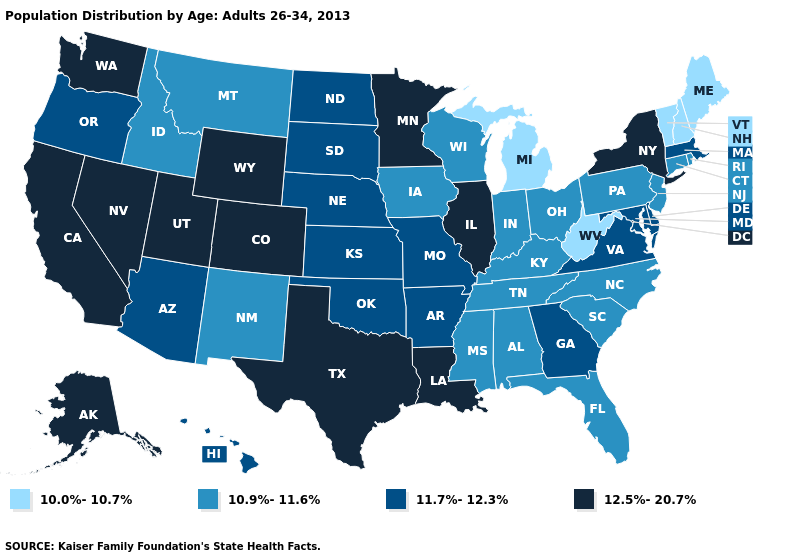Which states hav the highest value in the West?
Concise answer only. Alaska, California, Colorado, Nevada, Utah, Washington, Wyoming. Does the map have missing data?
Answer briefly. No. Name the states that have a value in the range 11.7%-12.3%?
Short answer required. Arizona, Arkansas, Delaware, Georgia, Hawaii, Kansas, Maryland, Massachusetts, Missouri, Nebraska, North Dakota, Oklahoma, Oregon, South Dakota, Virginia. Name the states that have a value in the range 12.5%-20.7%?
Answer briefly. Alaska, California, Colorado, Illinois, Louisiana, Minnesota, Nevada, New York, Texas, Utah, Washington, Wyoming. What is the value of Oklahoma?
Answer briefly. 11.7%-12.3%. What is the value of South Dakota?
Concise answer only. 11.7%-12.3%. What is the highest value in states that border Pennsylvania?
Answer briefly. 12.5%-20.7%. Does Virginia have the same value as Georgia?
Write a very short answer. Yes. Does Minnesota have the highest value in the MidWest?
Be succinct. Yes. Does Illinois have a higher value than New Hampshire?
Answer briefly. Yes. What is the value of Oklahoma?
Answer briefly. 11.7%-12.3%. Among the states that border Oregon , which have the highest value?
Write a very short answer. California, Nevada, Washington. What is the value of Oklahoma?
Keep it brief. 11.7%-12.3%. Among the states that border Wyoming , does Montana have the lowest value?
Be succinct. Yes. Does West Virginia have the lowest value in the USA?
Short answer required. Yes. 